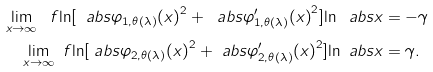Convert formula to latex. <formula><loc_0><loc_0><loc_500><loc_500>\lim _ { x \to \infty } \ f { \ln [ \ a b s { \varphi _ { 1 , \theta ( \lambda ) } ( x ) } ^ { 2 } + \ a b s { \varphi ^ { \prime } _ { 1 , \theta ( \lambda ) } ( x ) } ^ { 2 } ] } { \ln \ a b s { x } } & = - \gamma \\ \lim _ { x \to \infty } \ f { \ln [ \ a b s { \varphi _ { 2 , \theta ( \lambda ) } ( x ) } ^ { 2 } + \ a b s { \varphi ^ { \prime } _ { 2 , \theta ( \lambda ) } ( x ) } ^ { 2 } ] } { \ln \ a b s { x } } & = \gamma .</formula> 